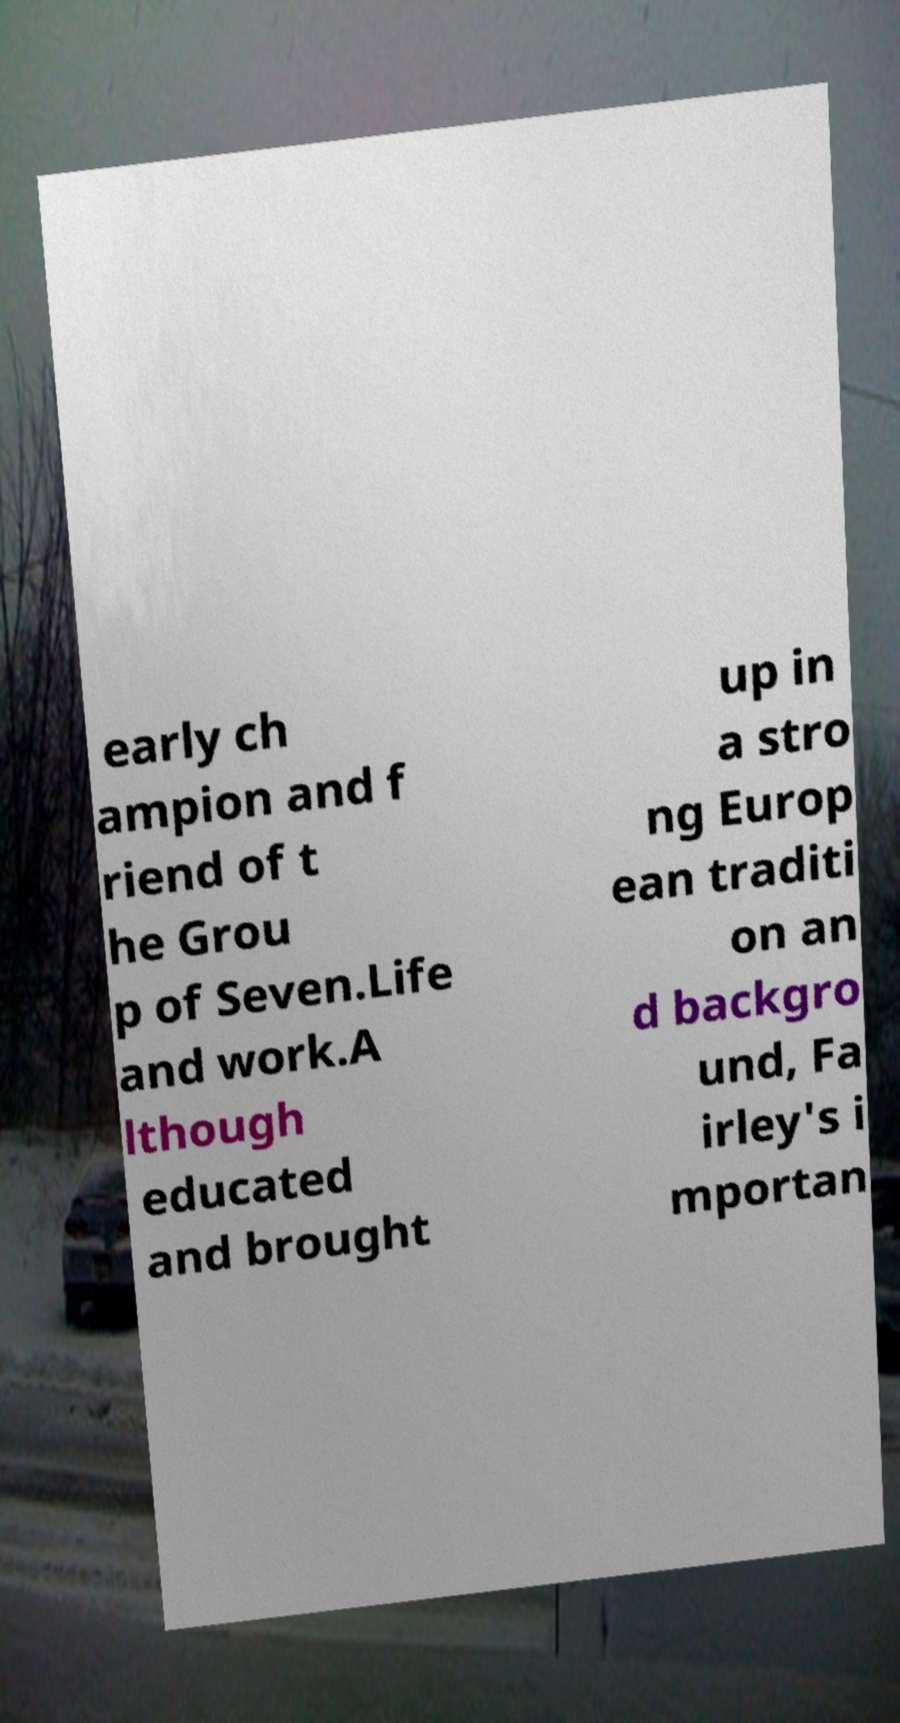There's text embedded in this image that I need extracted. Can you transcribe it verbatim? early ch ampion and f riend of t he Grou p of Seven.Life and work.A lthough educated and brought up in a stro ng Europ ean traditi on an d backgro und, Fa irley's i mportan 